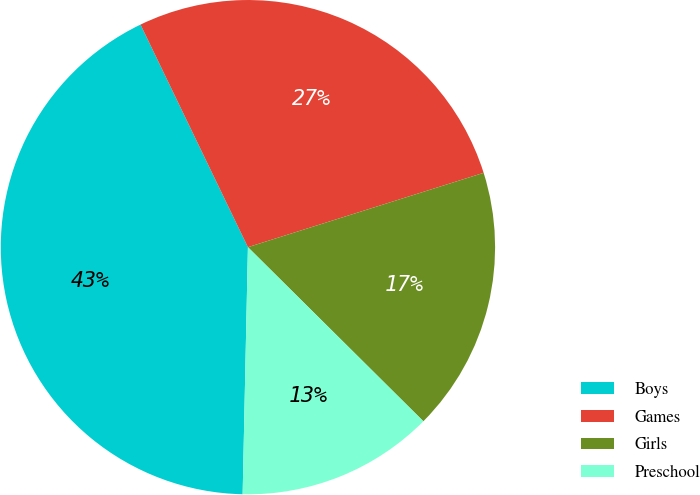Convert chart to OTSL. <chart><loc_0><loc_0><loc_500><loc_500><pie_chart><fcel>Boys<fcel>Games<fcel>Girls<fcel>Preschool<nl><fcel>42.5%<fcel>27.29%<fcel>17.3%<fcel>12.9%<nl></chart> 